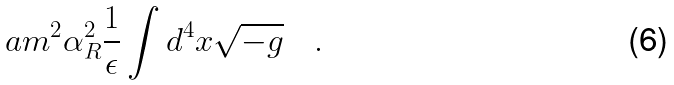Convert formula to latex. <formula><loc_0><loc_0><loc_500><loc_500>a m ^ { 2 } \alpha _ { R } ^ { 2 } \frac { 1 } { \epsilon } \int d ^ { 4 } x \sqrt { - g } \quad .</formula> 